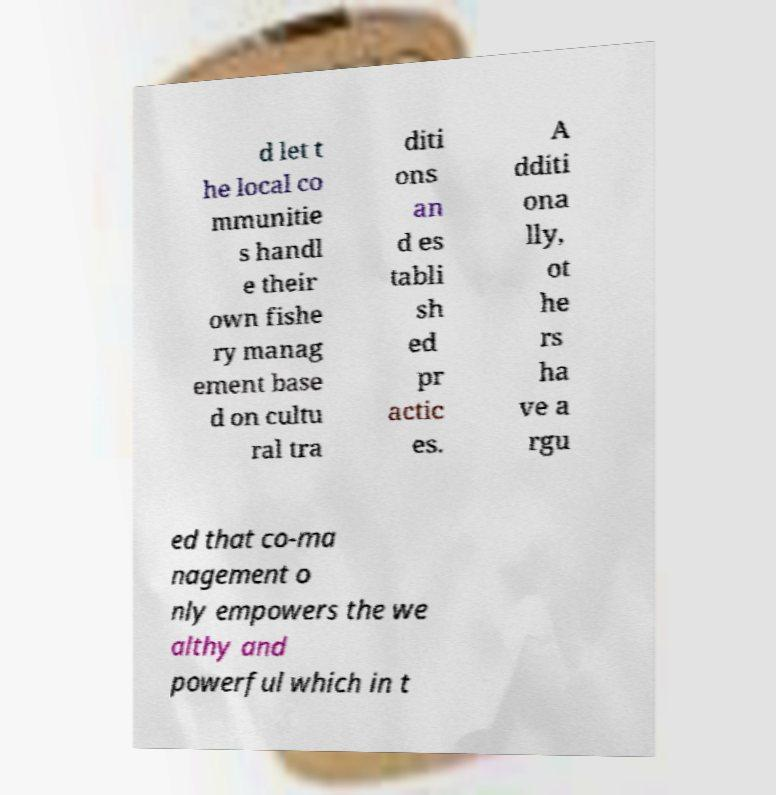For documentation purposes, I need the text within this image transcribed. Could you provide that? d let t he local co mmunitie s handl e their own fishe ry manag ement base d on cultu ral tra diti ons an d es tabli sh ed pr actic es. A dditi ona lly, ot he rs ha ve a rgu ed that co-ma nagement o nly empowers the we althy and powerful which in t 